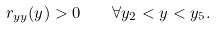Convert formula to latex. <formula><loc_0><loc_0><loc_500><loc_500>r _ { y y } ( y ) > 0 \quad \forall y _ { 2 } < y < y _ { 5 } .</formula> 